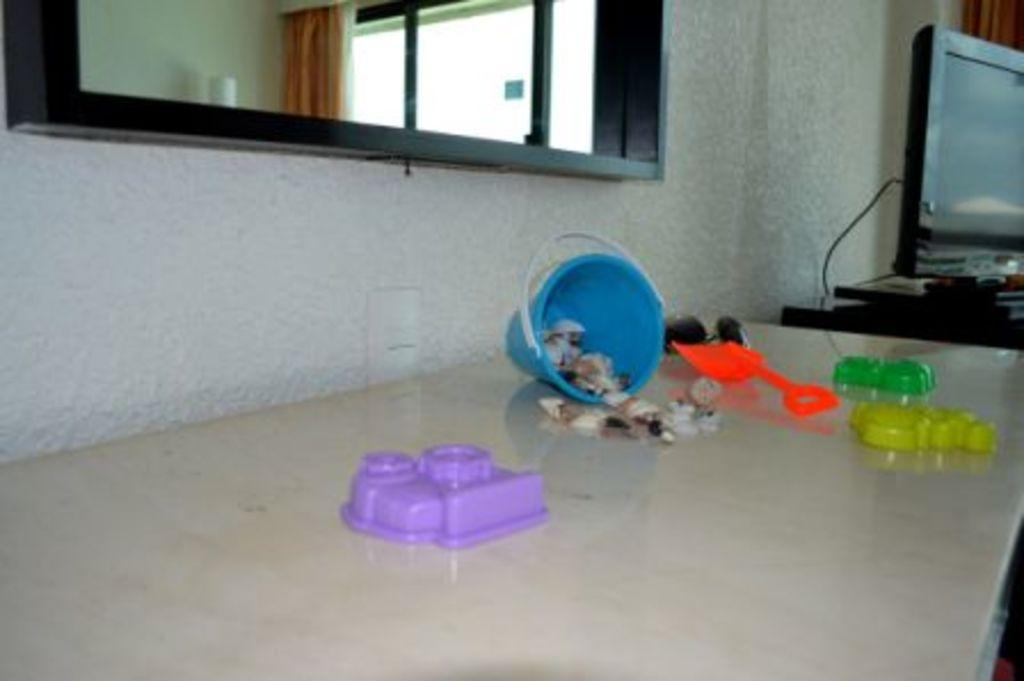What is the main piece of furniture in the image? There is a table in the image. What is placed on the table? There are toys on the table. What is located beside the table? There is a television beside the table. What can be seen in the background of the image? There is a wall and a window in the background of the image. What type of window treatment is present in the image? There is a curtain associated with the window. What type of border is visible around the toys on the table? There is no border visible around the toys on the table in the image. 